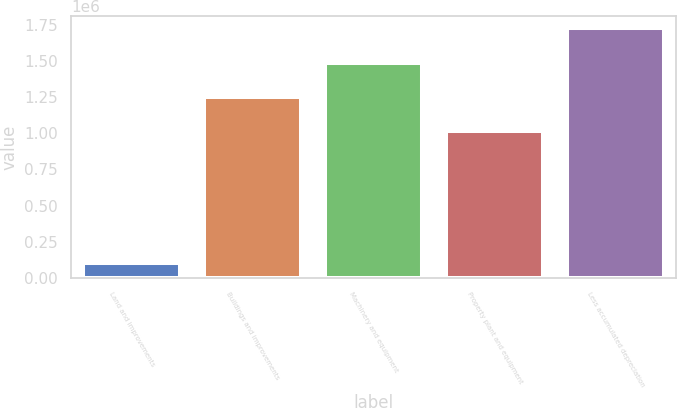<chart> <loc_0><loc_0><loc_500><loc_500><bar_chart><fcel>Land and improvements<fcel>Buildings and improvements<fcel>Machinery and equipment<fcel>Property plant and equipment<fcel>Less accumulated depreciation<nl><fcel>103158<fcel>1.24874e+06<fcel>1.48587e+06<fcel>1.01162e+06<fcel>1.723e+06<nl></chart> 